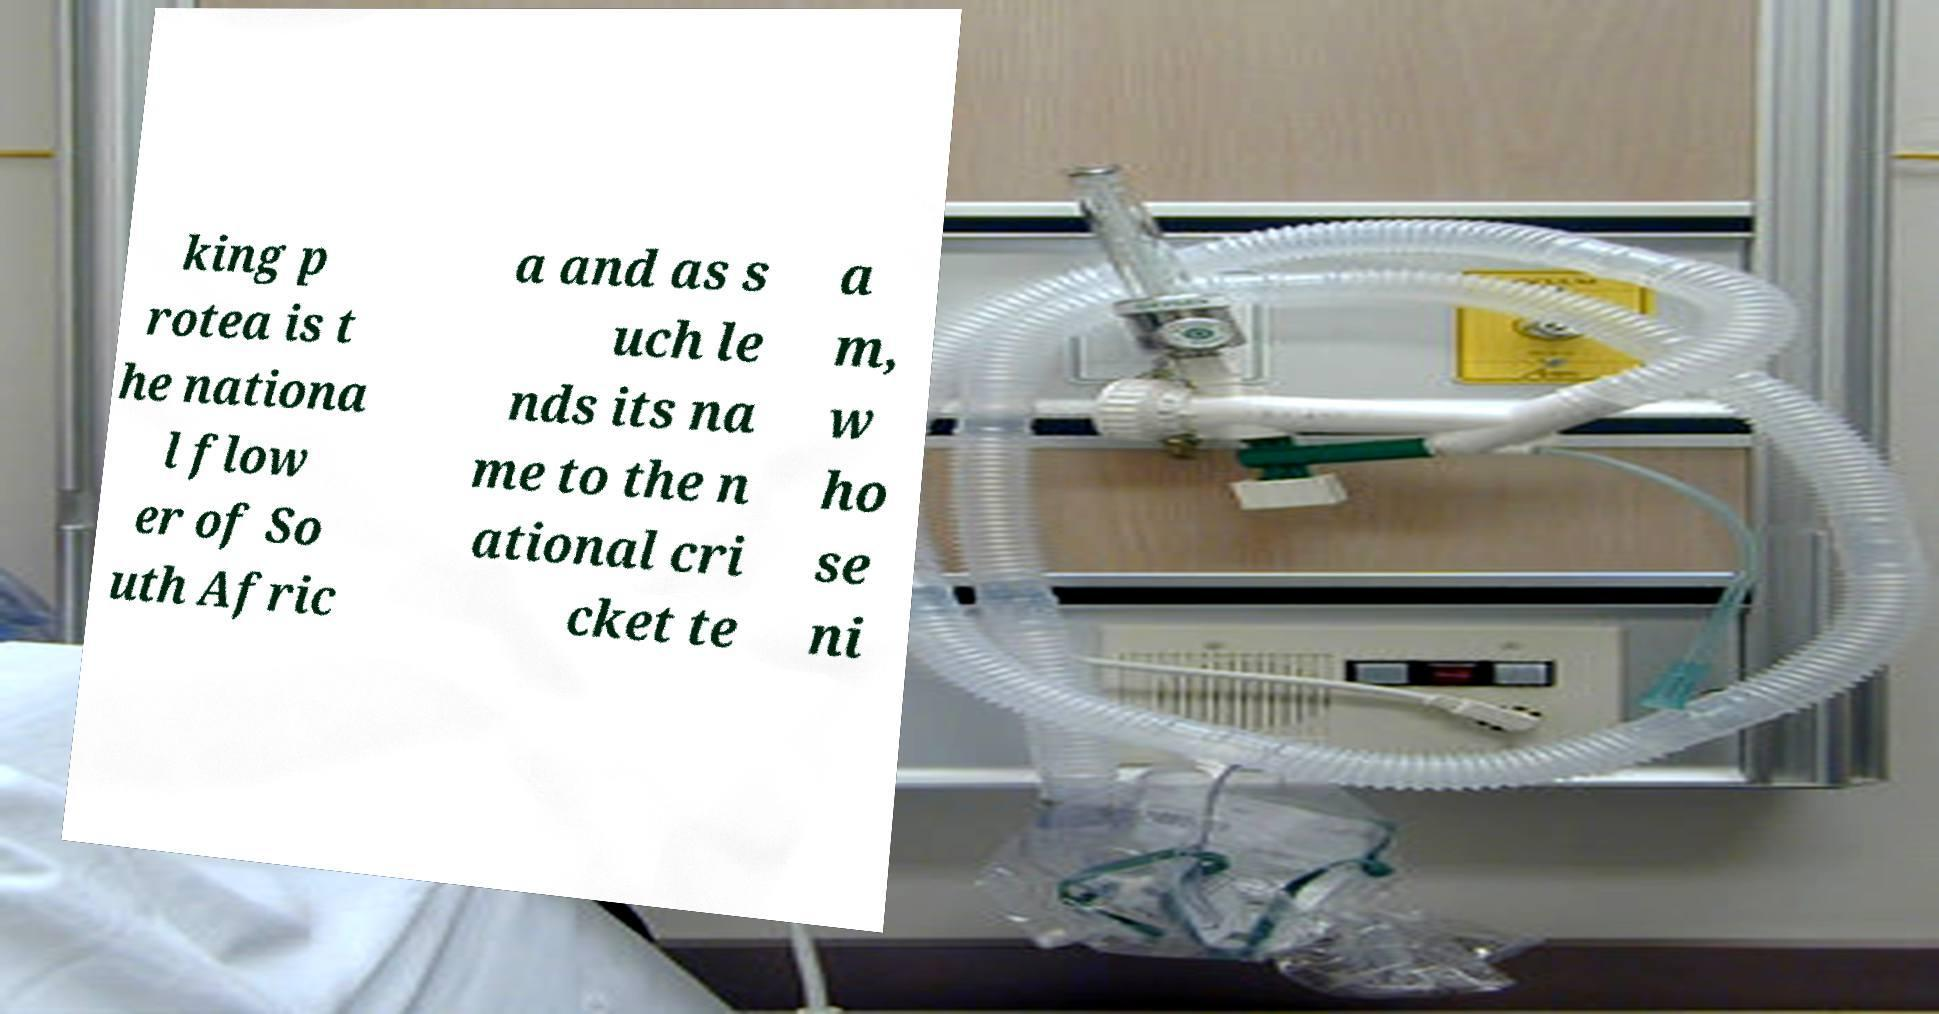There's text embedded in this image that I need extracted. Can you transcribe it verbatim? king p rotea is t he nationa l flow er of So uth Afric a and as s uch le nds its na me to the n ational cri cket te a m, w ho se ni 